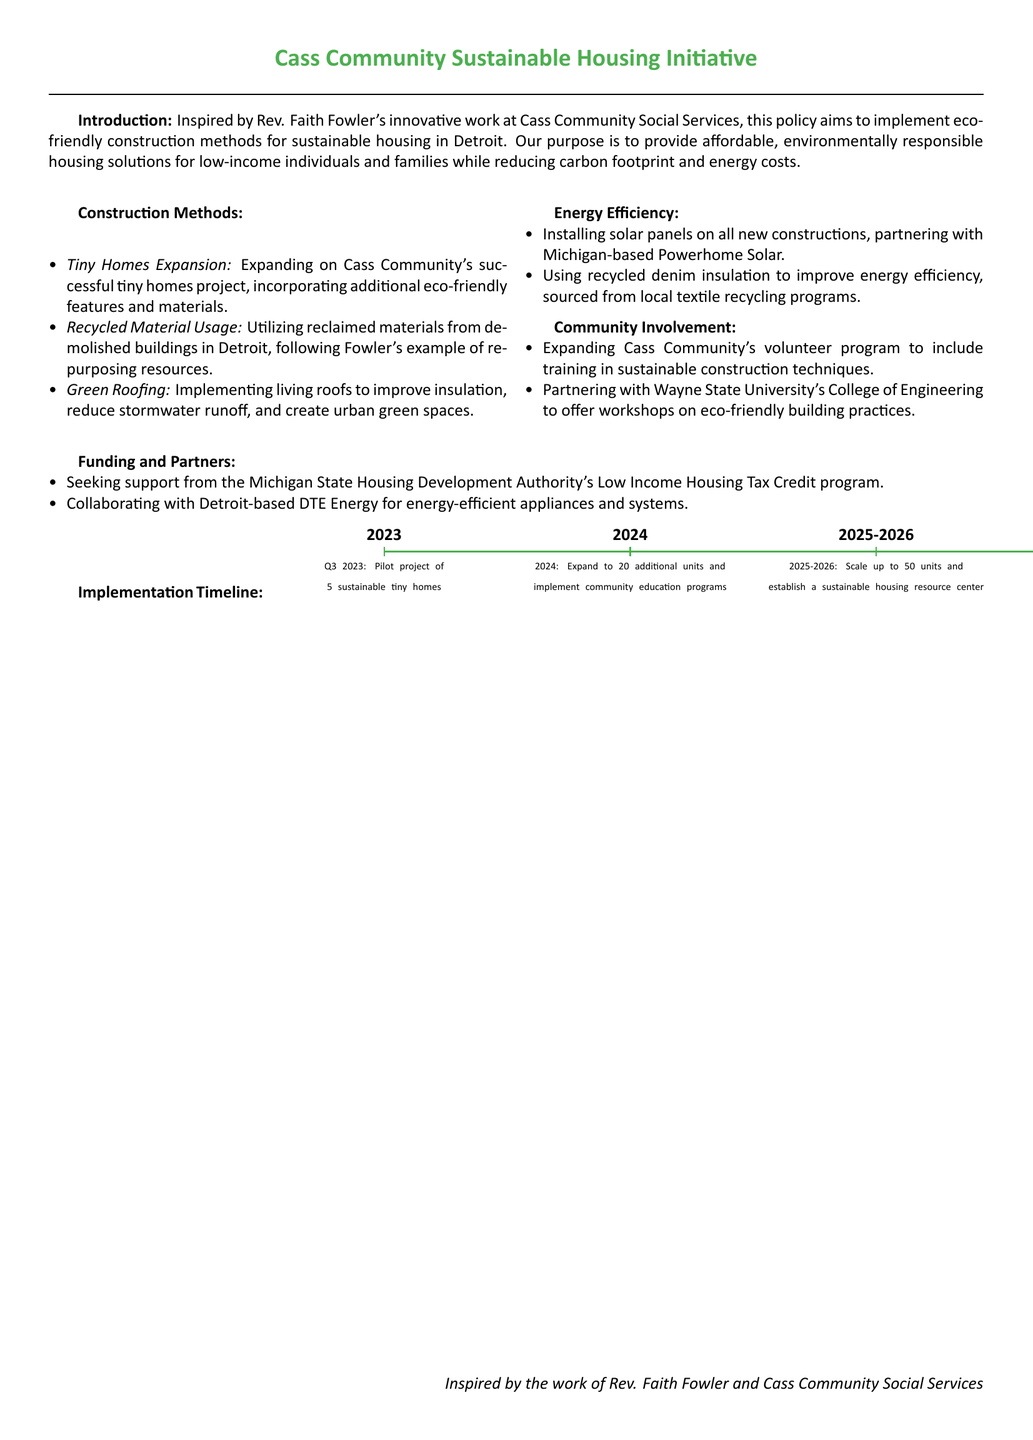What is the main purpose of the policy? The purpose is to provide affordable, environmentally responsible housing solutions while reducing carbon footprint and energy costs.
Answer: Provide affordable, environmentally responsible housing solutions What innovative construction method is being expanded upon? The document mentions the expansion of Cass Community's successful tiny homes project, incorporating additional eco-friendly features.
Answer: Tiny Homes Expansion What type of insulation is being used to improve energy efficiency? The policy specifies using recycled denim insulation sourced from local textile recycling programs.
Answer: Recycled denim insulation Who is partnering with the initiative for workshops on eco-friendly building practices? The document states that the partnership is with Wayne State University's College of Engineering.
Answer: Wayne State University What is the proposed timeline for scaling up to 50 units? The timeline indicates that scaling up to 50 units will happen from late 2025 to 2026.
Answer: 2025-2026 Which energy company is mentioned as a collaborator for energy-efficient appliances? The document names Detroit-based DTE Energy as a collaborator for energy-efficient systems.
Answer: DTE Energy What is a key feature of the green roofing implementation? The document highlights that living roofs improve insulation, reduce stormwater runoff, and create urban green spaces.
Answer: Improve insulation, reduce stormwater runoff Which program is the policy seeking support from for funding? The policy mentions seeking support from the Michigan State Housing Development Authority's Low Income Housing Tax Credit program.
Answer: Low Income Housing Tax Credit program How many sustainable tiny homes are proposed in the pilot project? The pilot project proposes building 5 sustainable tiny homes as specified in the document.
Answer: 5 